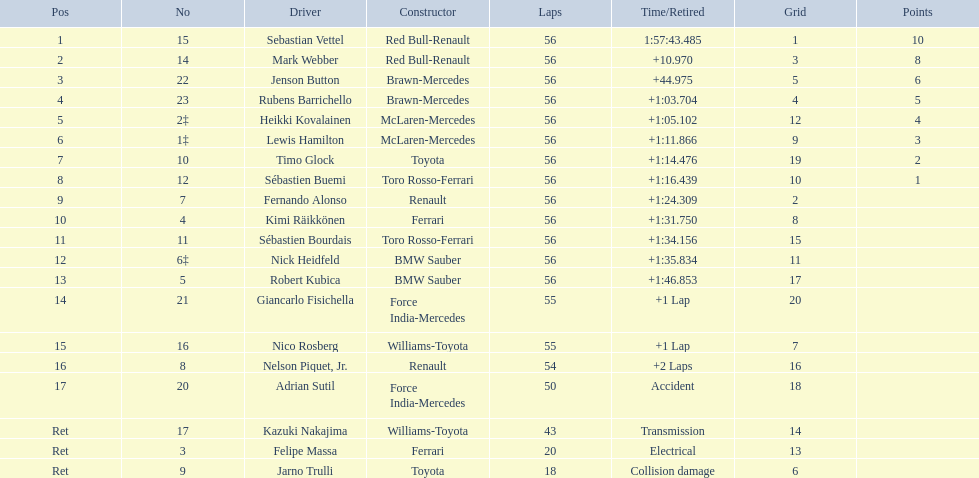Write the full table. {'header': ['Pos', 'No', 'Driver', 'Constructor', 'Laps', 'Time/Retired', 'Grid', 'Points'], 'rows': [['1', '15', 'Sebastian Vettel', 'Red Bull-Renault', '56', '1:57:43.485', '1', '10'], ['2', '14', 'Mark Webber', 'Red Bull-Renault', '56', '+10.970', '3', '8'], ['3', '22', 'Jenson Button', 'Brawn-Mercedes', '56', '+44.975', '5', '6'], ['4', '23', 'Rubens Barrichello', 'Brawn-Mercedes', '56', '+1:03.704', '4', '5'], ['5', '2‡', 'Heikki Kovalainen', 'McLaren-Mercedes', '56', '+1:05.102', '12', '4'], ['6', '1‡', 'Lewis Hamilton', 'McLaren-Mercedes', '56', '+1:11.866', '9', '3'], ['7', '10', 'Timo Glock', 'Toyota', '56', '+1:14.476', '19', '2'], ['8', '12', 'Sébastien Buemi', 'Toro Rosso-Ferrari', '56', '+1:16.439', '10', '1'], ['9', '7', 'Fernando Alonso', 'Renault', '56', '+1:24.309', '2', ''], ['10', '4', 'Kimi Räikkönen', 'Ferrari', '56', '+1:31.750', '8', ''], ['11', '11', 'Sébastien Bourdais', 'Toro Rosso-Ferrari', '56', '+1:34.156', '15', ''], ['12', '6‡', 'Nick Heidfeld', 'BMW Sauber', '56', '+1:35.834', '11', ''], ['13', '5', 'Robert Kubica', 'BMW Sauber', '56', '+1:46.853', '17', ''], ['14', '21', 'Giancarlo Fisichella', 'Force India-Mercedes', '55', '+1 Lap', '20', ''], ['15', '16', 'Nico Rosberg', 'Williams-Toyota', '55', '+1 Lap', '7', ''], ['16', '8', 'Nelson Piquet, Jr.', 'Renault', '54', '+2 Laps', '16', ''], ['17', '20', 'Adrian Sutil', 'Force India-Mercedes', '50', 'Accident', '18', ''], ['Ret', '17', 'Kazuki Nakajima', 'Williams-Toyota', '43', 'Transmission', '14', ''], ['Ret', '3', 'Felipe Massa', 'Ferrari', '20', 'Electrical', '13', ''], ['Ret', '9', 'Jarno Trulli', 'Toyota', '18', 'Collision damage', '6', '']]} Which competitors were involved in the 2009 chinese grand prix? Sebastian Vettel, Mark Webber, Jenson Button, Rubens Barrichello, Heikki Kovalainen, Lewis Hamilton, Timo Glock, Sébastien Buemi, Fernando Alonso, Kimi Räikkönen, Sébastien Bourdais, Nick Heidfeld, Robert Kubica, Giancarlo Fisichella, Nico Rosberg, Nelson Piquet, Jr., Adrian Sutil, Kazuki Nakajima, Felipe Massa, Jarno Trulli. Out of them, who completed the entire 56 laps? Sebastian Vettel, Mark Webber, Jenson Button, Rubens Barrichello, Heikki Kovalainen, Lewis Hamilton, Timo Glock, Sébastien Buemi, Fernando Alonso, Kimi Räikkönen, Sébastien Bourdais, Nick Heidfeld, Robert Kubica. Of those, in which did ferrari not compete as a constructor? Sebastian Vettel, Mark Webber, Jenson Button, Rubens Barrichello, Heikki Kovalainen, Lewis Hamilton, Timo Glock, Fernando Alonso, Kimi Räikkönen, Nick Heidfeld, Robert Kubica. Among the rest, who is in the first place? Sebastian Vettel. 